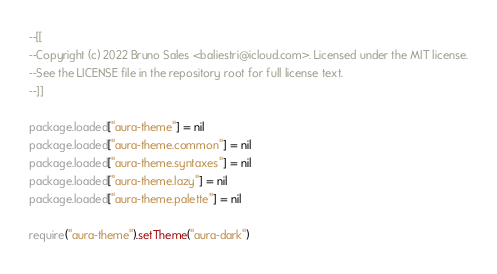Convert code to text. <code><loc_0><loc_0><loc_500><loc_500><_Lua_>--[[
--Copyright (c) 2022 Bruno Sales <baliestri@icloud.com>. Licensed under the MIT license.
--See the LICENSE file in the repository root for full license text.
--]]

package.loaded["aura-theme"] = nil
package.loaded["aura-theme.common"] = nil
package.loaded["aura-theme.syntaxes"] = nil
package.loaded["aura-theme.lazy"] = nil
package.loaded["aura-theme.palette"] = nil

require("aura-theme").setTheme("aura-dark")
</code> 